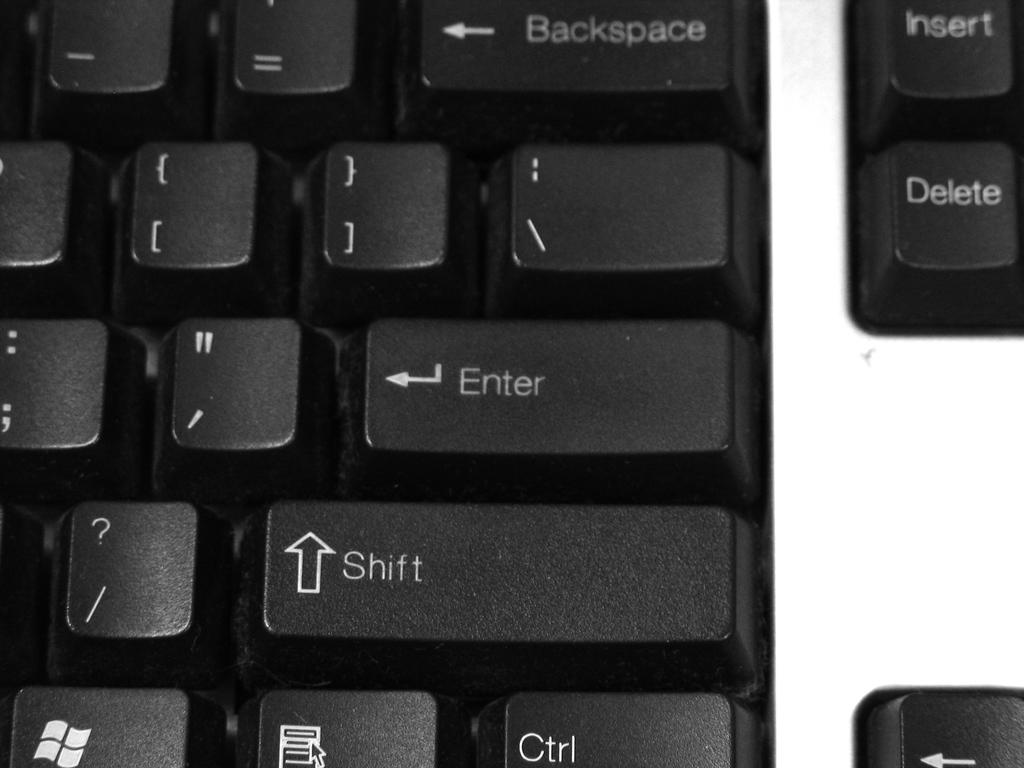<image>
Present a compact description of the photo's key features. A close up of a keyboard's enter and shift key 